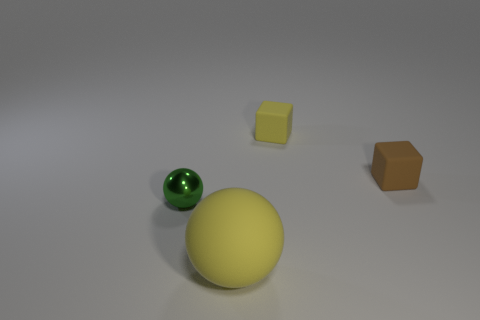Add 3 tiny gray metallic spheres. How many objects exist? 7 Add 1 small blocks. How many small blocks exist? 3 Subtract 0 blue cylinders. How many objects are left? 4 Subtract all tiny cyan shiny cylinders. Subtract all brown matte objects. How many objects are left? 3 Add 4 brown cubes. How many brown cubes are left? 5 